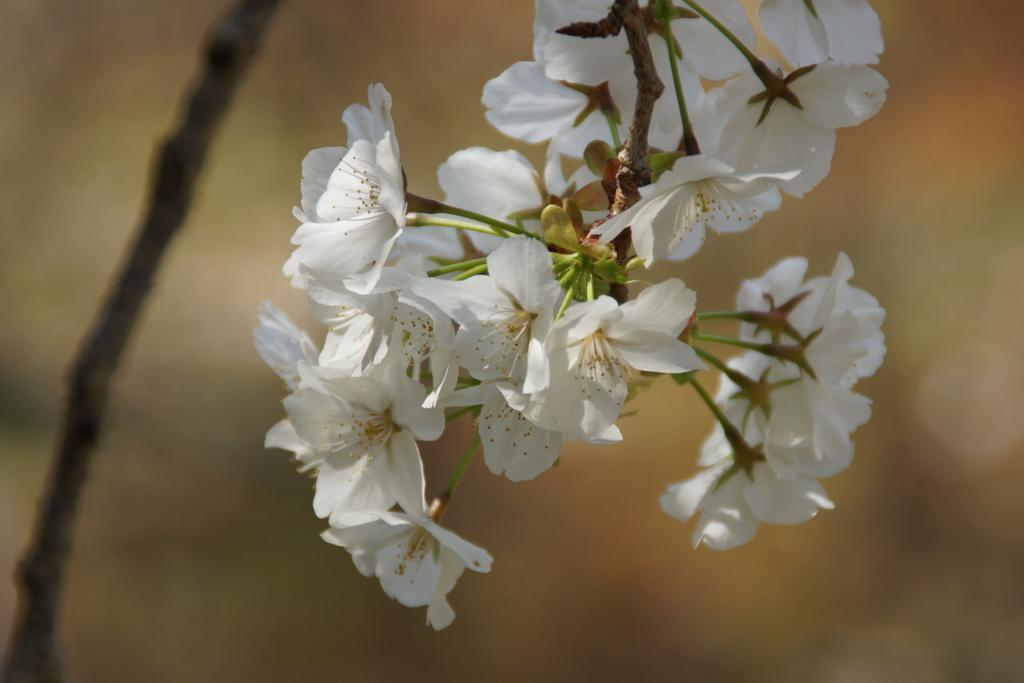What type of flowers can be seen in the image? There are white flowers in the image. What object is on the left side of the image? There is a wooden stick on the left side of the image. Can you describe the background of the image? The background of the image is blurry. What design is agreed upon by the boys in the image? There are no boys present in the image, and no design or agreement is mentioned. 